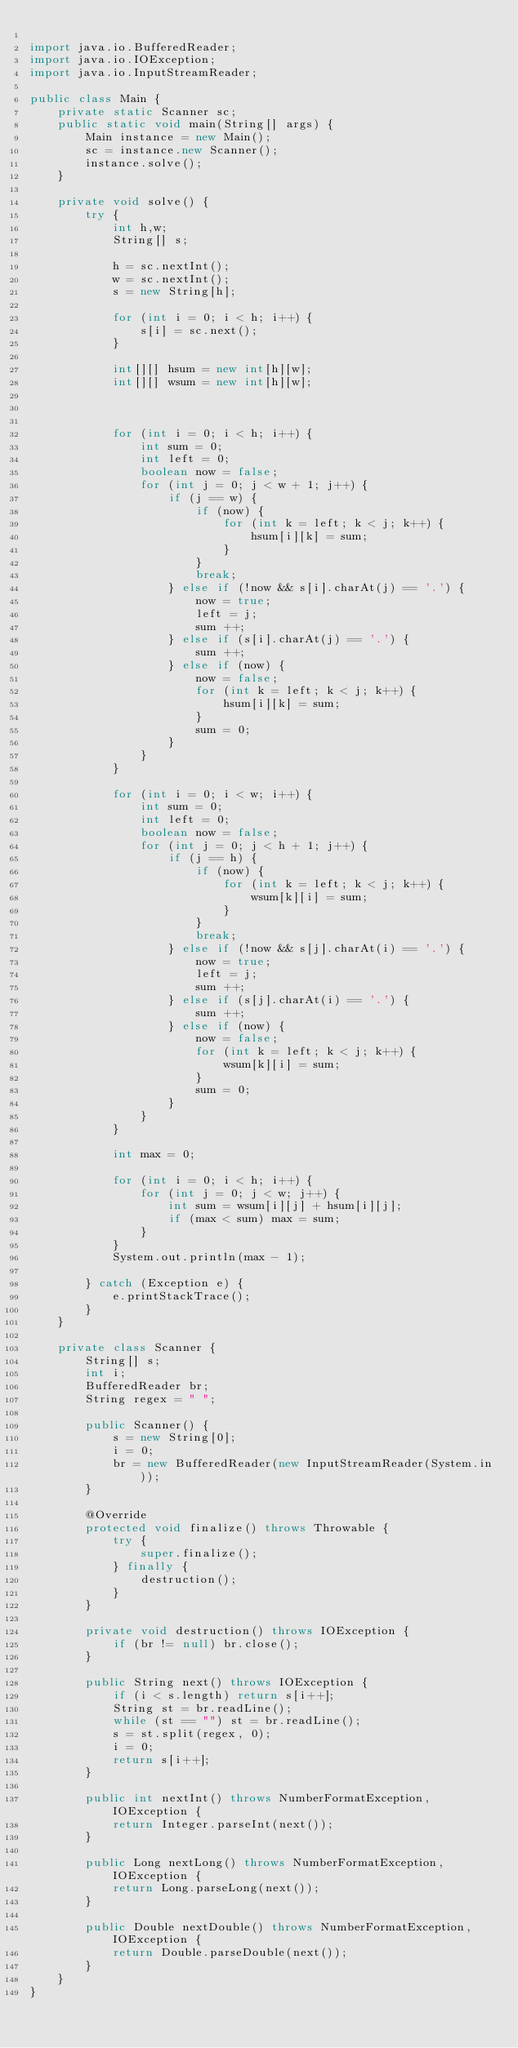<code> <loc_0><loc_0><loc_500><loc_500><_Java_>
import java.io.BufferedReader;
import java.io.IOException;
import java.io.InputStreamReader;

public class Main {
    private static Scanner sc;
    public static void main(String[] args) {
        Main instance = new Main();
        sc = instance.new Scanner();
        instance.solve();
    }

    private void solve() {
        try {
            int h,w;
            String[] s;

            h = sc.nextInt();
            w = sc.nextInt();
            s = new String[h];

            for (int i = 0; i < h; i++) {
                s[i] = sc.next();
            }

            int[][] hsum = new int[h][w];
            int[][] wsum = new int[h][w];



            for (int i = 0; i < h; i++) {
                int sum = 0;
                int left = 0;
                boolean now = false;
                for (int j = 0; j < w + 1; j++) {
                    if (j == w) {
                        if (now) {
                            for (int k = left; k < j; k++) {
                                hsum[i][k] = sum;
                            }
                        }
                        break;
                    } else if (!now && s[i].charAt(j) == '.') {
                        now = true;
                        left = j;
                        sum ++;
                    } else if (s[i].charAt(j) == '.') {
                        sum ++;
                    } else if (now) {
                        now = false;
                        for (int k = left; k < j; k++) {
                            hsum[i][k] = sum;
                        }
                        sum = 0;
                    }
                }
            }

            for (int i = 0; i < w; i++) {
                int sum = 0;
                int left = 0;
                boolean now = false;
                for (int j = 0; j < h + 1; j++) {
                    if (j == h) {
                        if (now) {
                            for (int k = left; k < j; k++) {
                                wsum[k][i] = sum;
                            }
                        }
                        break;
                    } else if (!now && s[j].charAt(i) == '.') {
                        now = true;
                        left = j;
                        sum ++;
                    } else if (s[j].charAt(i) == '.') {
                        sum ++;
                    } else if (now) {
                        now = false;
                        for (int k = left; k < j; k++) {
                            wsum[k][i] = sum;
                        }
                        sum = 0;
                    }
                }
            }

            int max = 0;

            for (int i = 0; i < h; i++) {
                for (int j = 0; j < w; j++) {
                    int sum = wsum[i][j] + hsum[i][j];
                    if (max < sum) max = sum;
                }
            }
            System.out.println(max - 1);

        } catch (Exception e) {
            e.printStackTrace();
        }
    }

    private class Scanner {
        String[] s;
        int i;
        BufferedReader br;
        String regex = " ";

        public Scanner() {
            s = new String[0];
            i = 0;
            br = new BufferedReader(new InputStreamReader(System.in));
        }

        @Override
        protected void finalize() throws Throwable {
            try {
                super.finalize();
            } finally {
                destruction();
            }
        }

        private void destruction() throws IOException {
            if (br != null) br.close();
        }

        public String next() throws IOException {
            if (i < s.length) return s[i++];
            String st = br.readLine();
            while (st == "") st = br.readLine();
            s = st.split(regex, 0);
            i = 0;
            return s[i++];
        }

        public int nextInt() throws NumberFormatException, IOException {
            return Integer.parseInt(next());
        }

        public Long nextLong() throws NumberFormatException, IOException {
            return Long.parseLong(next());
        }

        public Double nextDouble() throws NumberFormatException, IOException {
            return Double.parseDouble(next());
        }
    }
}</code> 